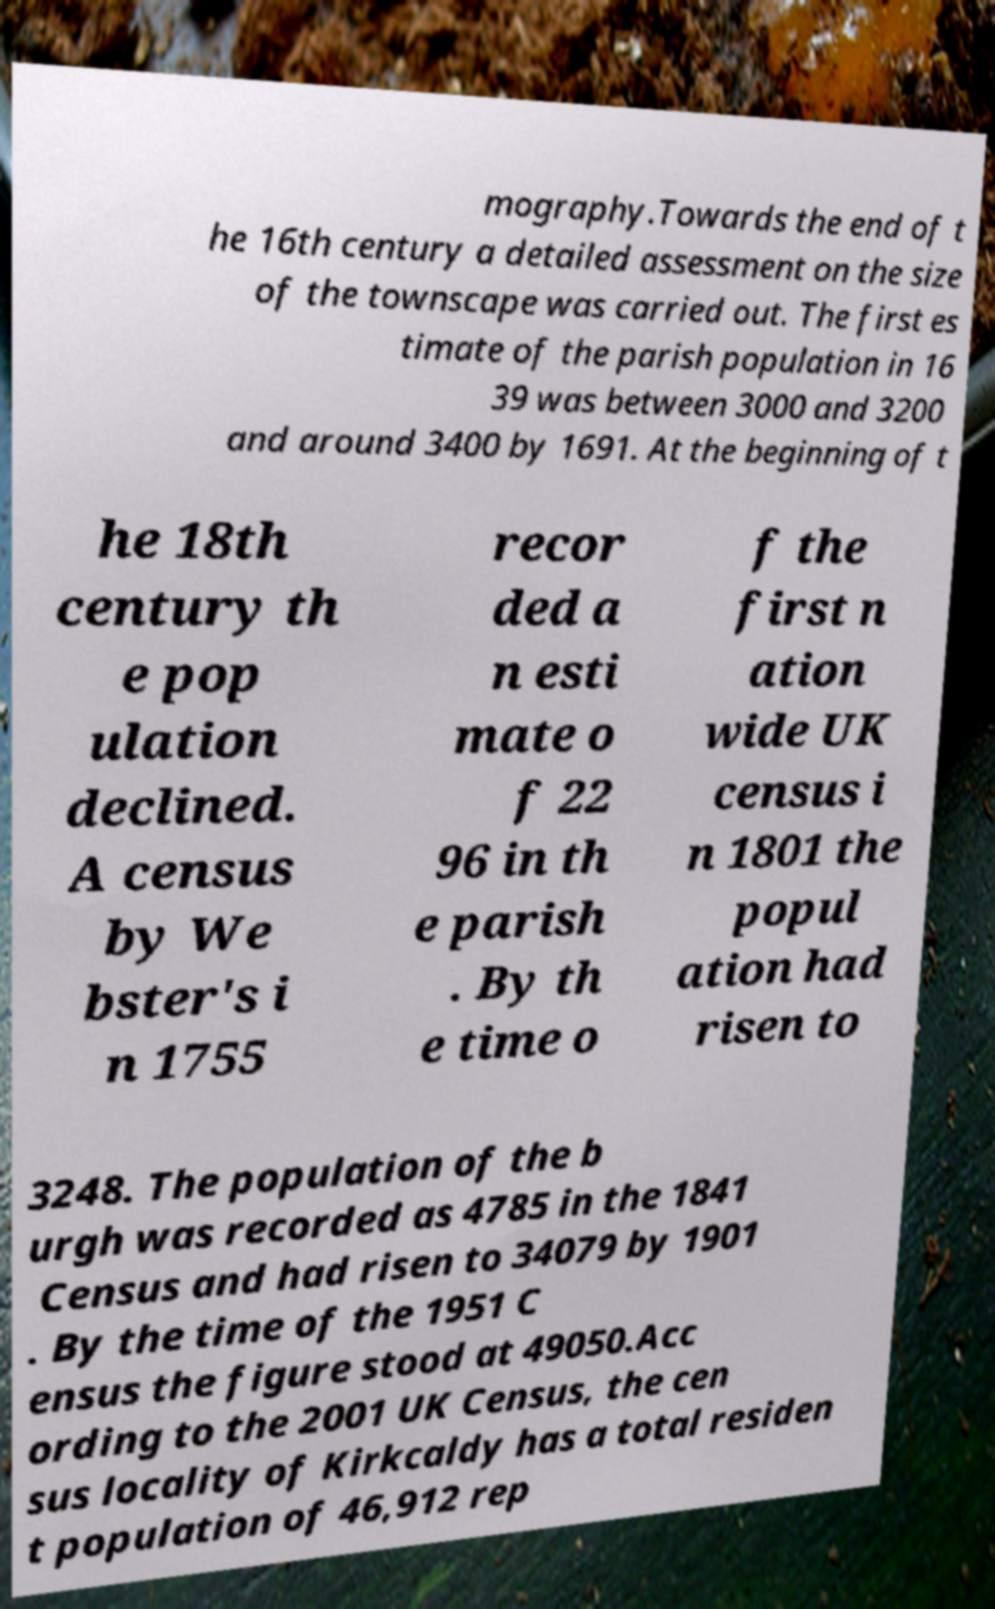Could you extract and type out the text from this image? mography.Towards the end of t he 16th century a detailed assessment on the size of the townscape was carried out. The first es timate of the parish population in 16 39 was between 3000 and 3200 and around 3400 by 1691. At the beginning of t he 18th century th e pop ulation declined. A census by We bster's i n 1755 recor ded a n esti mate o f 22 96 in th e parish . By th e time o f the first n ation wide UK census i n 1801 the popul ation had risen to 3248. The population of the b urgh was recorded as 4785 in the 1841 Census and had risen to 34079 by 1901 . By the time of the 1951 C ensus the figure stood at 49050.Acc ording to the 2001 UK Census, the cen sus locality of Kirkcaldy has a total residen t population of 46,912 rep 